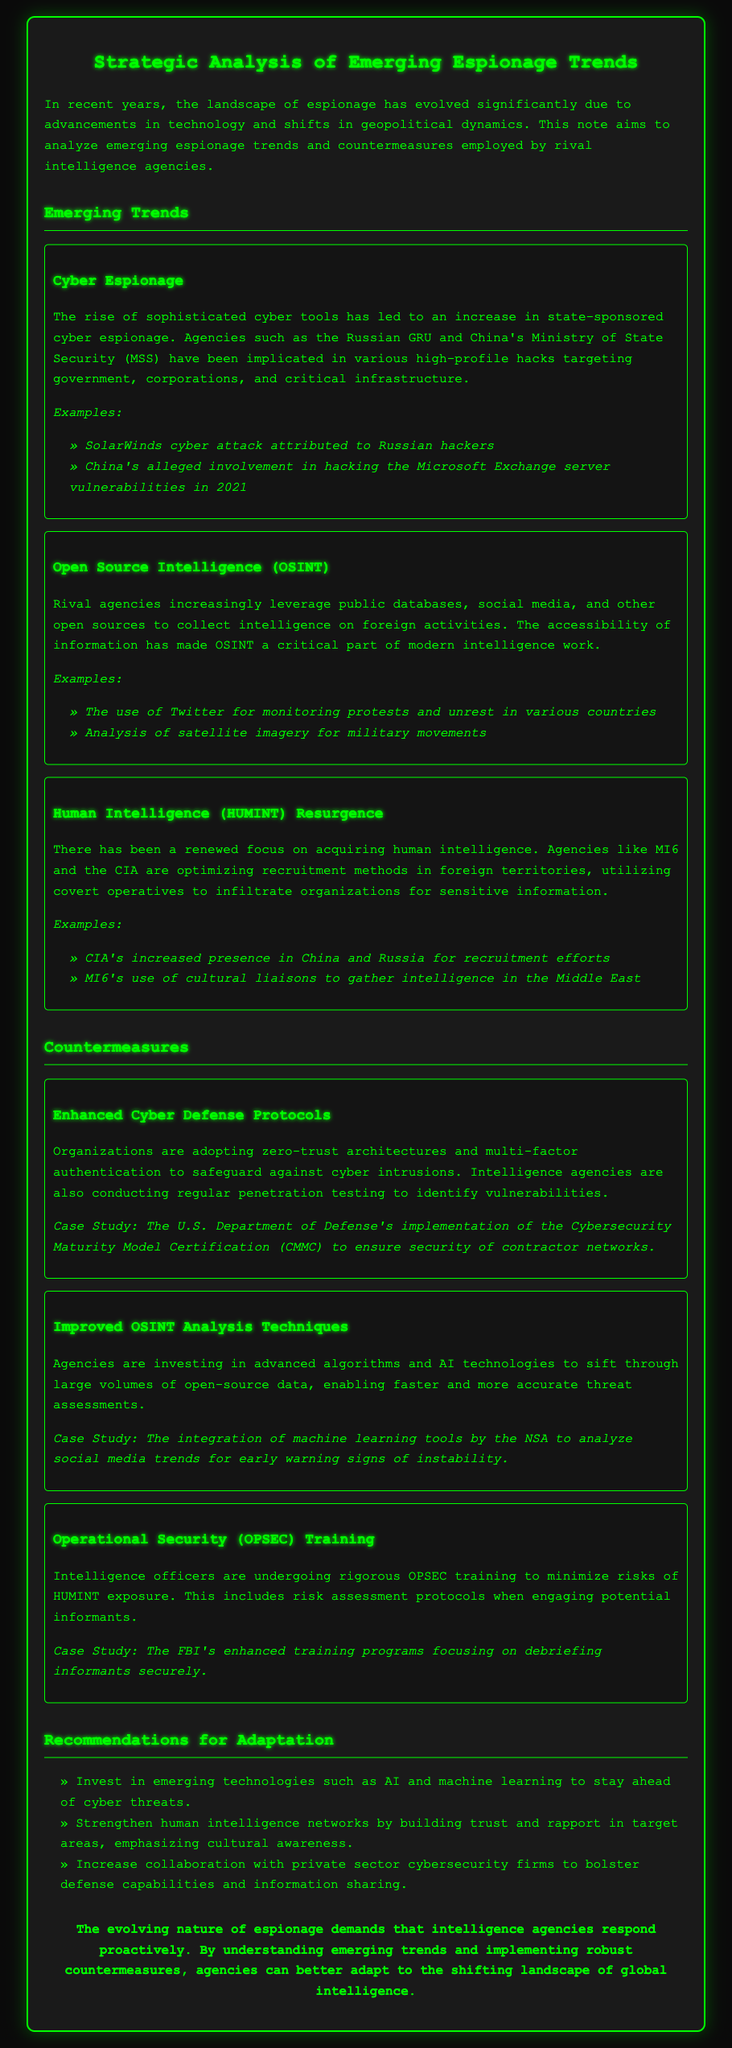What are the three emerging trends in espionage? The document lists Cyber Espionage, Open Source Intelligence (OSINT), and Human Intelligence (HUMINT) Resurgence as emerging trends.
Answer: Cyber Espionage, Open Source Intelligence (OSINT), Human Intelligence (HUMINT) Resurgence Which agency is mentioned as using advanced algorithms for OSINT analysis? The document mentions the NSA as integrating machine learning tools for OSINT analysis.
Answer: NSA What case study is referenced for Enhanced Cyber Defense Protocols? The case study refers to the U.S. Department of Defense's implementation of the Cybersecurity Maturity Model Certification (CMMC).
Answer: U.S. Department of Defense's implementation of the Cybersecurity Maturity Model Certification (CMMC) What is one suggested recommendation for adaptation? The document suggests investing in emerging technologies such as AI and machine learning to stay ahead of cyber threats.
Answer: Invest in emerging technologies such as AI and machine learning Who are the rival agencies implicated in cyber espionage? The document specifically mentions the Russian GRU and China's Ministry of State Security (MSS) for state-sponsored cyber espionage activities.
Answer: Russian GRU and China's Ministry of State Security (MSS) What is the primary focus of the document? The document focuses on analyzing emerging espionage trends and countermeasures employed by rival intelligence agencies.
Answer: Analyzing emerging espionage trends and countermeasures 